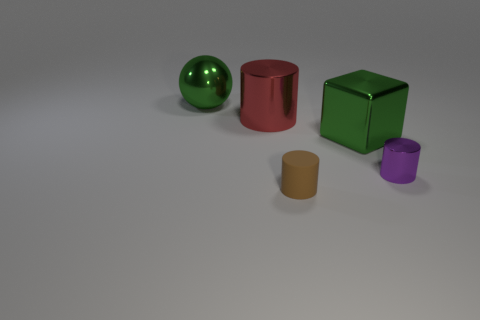Subtract all brown matte cylinders. How many cylinders are left? 2 Add 3 big metallic balls. How many objects exist? 8 Subtract all cyan cylinders. Subtract all cyan spheres. How many cylinders are left? 3 Subtract all cylinders. How many objects are left? 2 Subtract 0 yellow spheres. How many objects are left? 5 Subtract all shiny blocks. Subtract all green shiny balls. How many objects are left? 3 Add 2 large metallic cylinders. How many large metallic cylinders are left? 3 Add 3 tiny yellow balls. How many tiny yellow balls exist? 3 